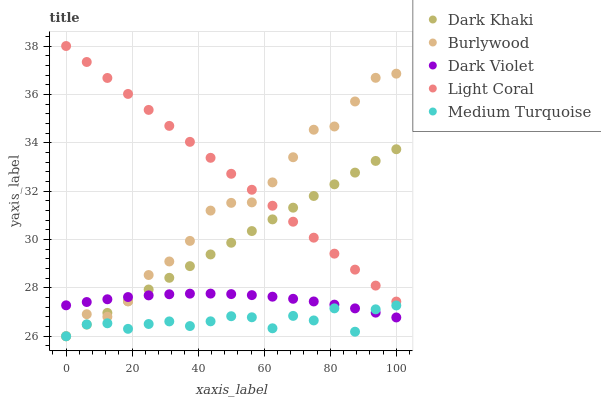Does Medium Turquoise have the minimum area under the curve?
Answer yes or no. Yes. Does Light Coral have the maximum area under the curve?
Answer yes or no. Yes. Does Burlywood have the minimum area under the curve?
Answer yes or no. No. Does Burlywood have the maximum area under the curve?
Answer yes or no. No. Is Dark Khaki the smoothest?
Answer yes or no. Yes. Is Medium Turquoise the roughest?
Answer yes or no. Yes. Is Burlywood the smoothest?
Answer yes or no. No. Is Burlywood the roughest?
Answer yes or no. No. Does Dark Khaki have the lowest value?
Answer yes or no. Yes. Does Light Coral have the lowest value?
Answer yes or no. No. Does Light Coral have the highest value?
Answer yes or no. Yes. Does Burlywood have the highest value?
Answer yes or no. No. Is Dark Violet less than Light Coral?
Answer yes or no. Yes. Is Light Coral greater than Medium Turquoise?
Answer yes or no. Yes. Does Light Coral intersect Burlywood?
Answer yes or no. Yes. Is Light Coral less than Burlywood?
Answer yes or no. No. Is Light Coral greater than Burlywood?
Answer yes or no. No. Does Dark Violet intersect Light Coral?
Answer yes or no. No. 